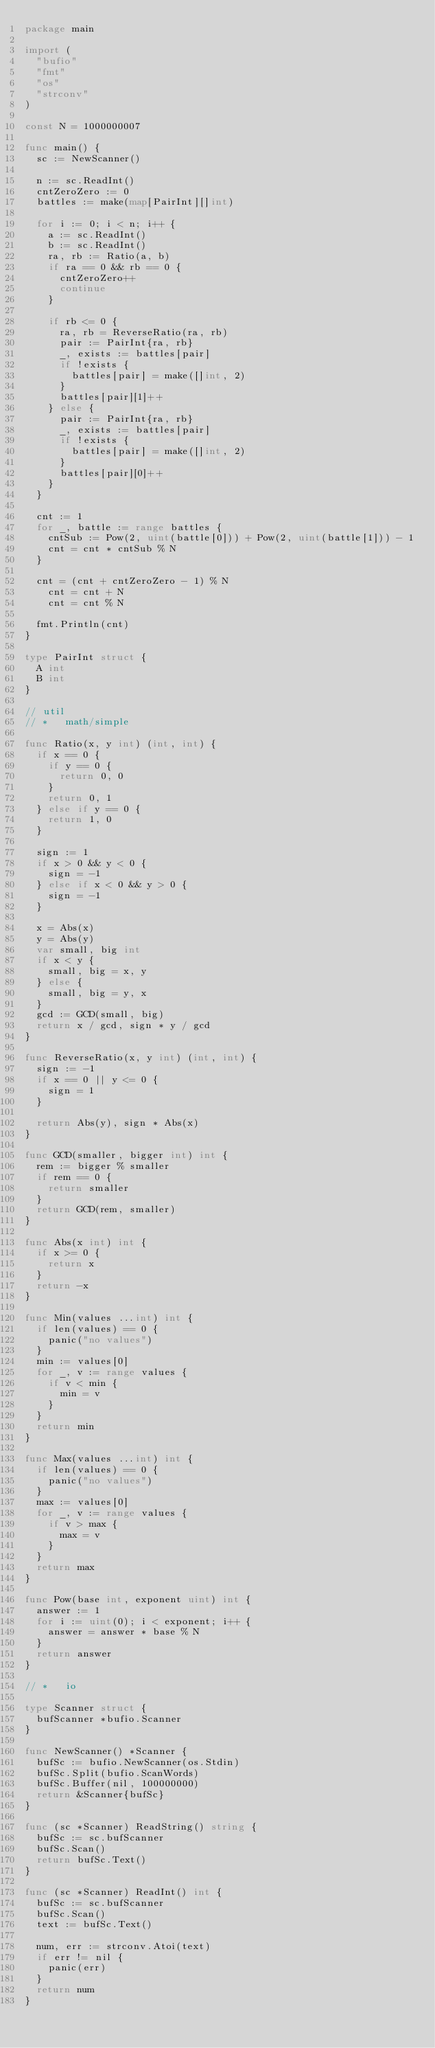<code> <loc_0><loc_0><loc_500><loc_500><_Go_>package main

import (
	"bufio"
	"fmt"
	"os"
	"strconv"
)

const N = 1000000007

func main() {
	sc := NewScanner()

	n := sc.ReadInt()
	cntZeroZero := 0
	battles := make(map[PairInt][]int)

	for i := 0; i < n; i++ {
		a := sc.ReadInt()
		b := sc.ReadInt()
		ra, rb := Ratio(a, b)
		if ra == 0 && rb == 0 {
			cntZeroZero++
			continue
		}

		if rb <= 0 {
			ra, rb = ReverseRatio(ra, rb)
			pair := PairInt{ra, rb}
			_, exists := battles[pair]
			if !exists {
				battles[pair] = make([]int, 2)
			}
			battles[pair][1]++
		} else {
			pair := PairInt{ra, rb}
			_, exists := battles[pair]
			if !exists {
				battles[pair] = make([]int, 2)
			}
			battles[pair][0]++
		}
	}

	cnt := 1
	for _, battle := range battles {
		cntSub := Pow(2, uint(battle[0])) + Pow(2, uint(battle[1])) - 1
		cnt = cnt * cntSub % N
	}

	cnt = (cnt + cntZeroZero - 1) % N
  	cnt = cnt + N
    cnt = cnt % N

	fmt.Println(cnt)
}

type PairInt struct {
	A int
	B int
}

// util
// *   math/simple

func Ratio(x, y int) (int, int) {
	if x == 0 {
		if y == 0 {
			return 0, 0
		}
		return 0, 1
	} else if y == 0 {
		return 1, 0
	}

	sign := 1
	if x > 0 && y < 0 {
		sign = -1
	} else if x < 0 && y > 0 {
		sign = -1
	}

	x = Abs(x)
	y = Abs(y)
	var small, big int
	if x < y {
		small, big = x, y
	} else {
		small, big = y, x
	}
	gcd := GCD(small, big)
	return x / gcd, sign * y / gcd
}

func ReverseRatio(x, y int) (int, int) {
	sign := -1
	if x == 0 || y <= 0 {
		sign = 1
	}

	return Abs(y), sign * Abs(x)
}

func GCD(smaller, bigger int) int {
	rem := bigger % smaller
	if rem == 0 {
		return smaller
	}
	return GCD(rem, smaller)
}

func Abs(x int) int {
	if x >= 0 {
		return x
	}
	return -x
}

func Min(values ...int) int {
	if len(values) == 0 {
		panic("no values")
	}
	min := values[0]
	for _, v := range values {
		if v < min {
			min = v
		}
	}
	return min
}

func Max(values ...int) int {
	if len(values) == 0 {
		panic("no values")
	}
	max := values[0]
	for _, v := range values {
		if v > max {
			max = v
		}
	}
	return max
}

func Pow(base int, exponent uint) int {
	answer := 1
	for i := uint(0); i < exponent; i++ {
		answer = answer * base % N
	}
	return answer
}

// *   io

type Scanner struct {
	bufScanner *bufio.Scanner
}

func NewScanner() *Scanner {
	bufSc := bufio.NewScanner(os.Stdin)
	bufSc.Split(bufio.ScanWords)
	bufSc.Buffer(nil, 100000000)
	return &Scanner{bufSc}
}

func (sc *Scanner) ReadString() string {
	bufSc := sc.bufScanner
	bufSc.Scan()
	return bufSc.Text()
}

func (sc *Scanner) ReadInt() int {
	bufSc := sc.bufScanner
	bufSc.Scan()
	text := bufSc.Text()

	num, err := strconv.Atoi(text)
	if err != nil {
		panic(err)
	}
	return num
}
</code> 